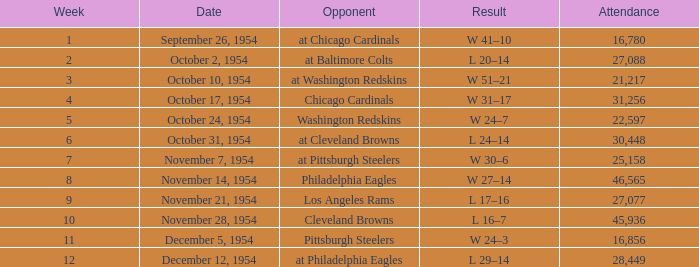How many weeks have october 31, 1954 as the date? 1.0. 